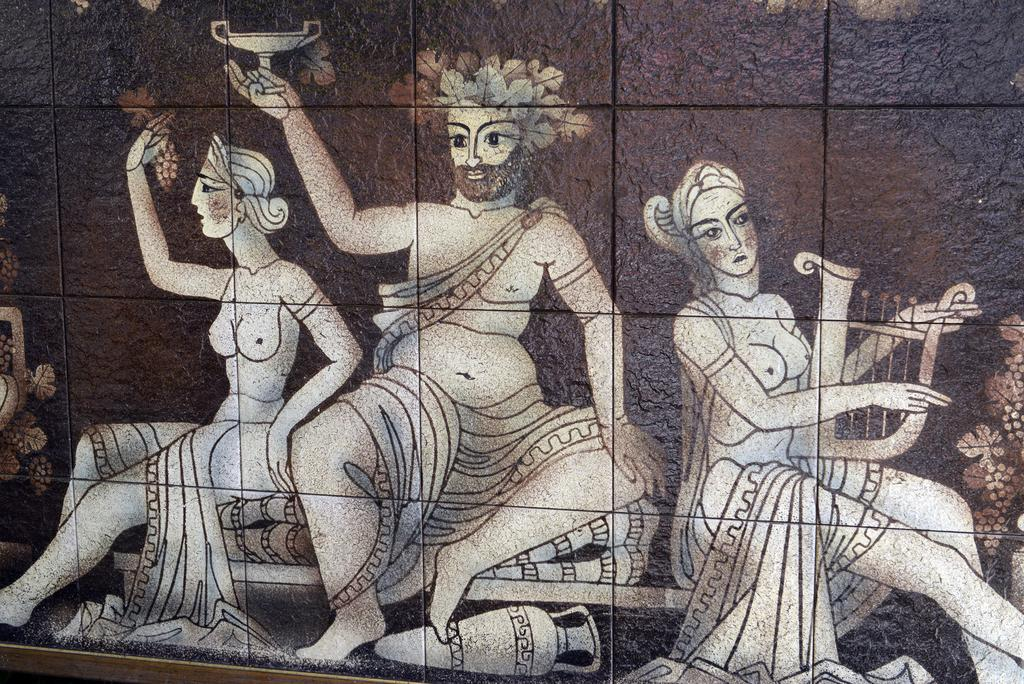What is the color and material of the wall in the image? The wall in the image is a brown color stone wall. What is depicted in the painting on the wall? The painting on the wall features a man and two women sitting. Can you describe any other objects in the image besides the wall and painting? Yes, there is a pot in the image. What type of interest can be seen growing on the wall in the image? There is no mention of any interest growing on the wall in the image; it is a stone wall with a painting on it. 